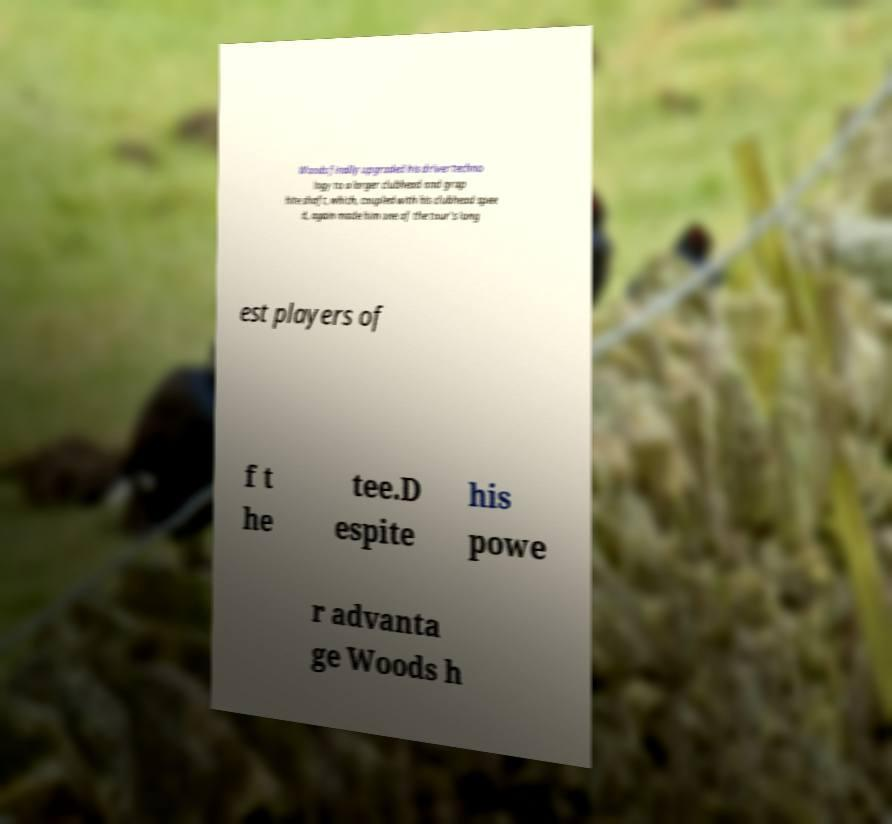What messages or text are displayed in this image? I need them in a readable, typed format. Woods finally upgraded his driver techno logy to a larger clubhead and grap hite shaft, which, coupled with his clubhead spee d, again made him one of the tour's long est players of f t he tee.D espite his powe r advanta ge Woods h 